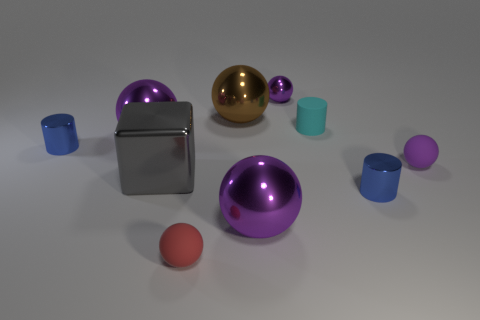Are there any small spheres made of the same material as the gray thing?
Your answer should be very brief. Yes. What size is the rubber object that is the same color as the small metal sphere?
Your answer should be compact. Small. How many gray things are either large things or big cubes?
Your answer should be very brief. 1. Is there a rubber ball that has the same color as the tiny metal ball?
Make the answer very short. Yes. There is another sphere that is the same material as the red ball; what is its size?
Your response must be concise. Small. How many cylinders are small gray shiny things or cyan things?
Offer a very short reply. 1. Are there more purple matte objects than rubber objects?
Make the answer very short. No. How many purple rubber objects have the same size as the cyan matte thing?
Make the answer very short. 1. There is a tiny matte object that is the same color as the tiny shiny ball; what shape is it?
Offer a very short reply. Sphere. How many things are either rubber things to the left of the small purple matte sphere or big red blocks?
Keep it short and to the point. 2. 